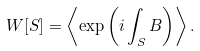Convert formula to latex. <formula><loc_0><loc_0><loc_500><loc_500>W [ S ] = \left \langle \exp \left ( i \int _ { S } B \right ) \right \rangle .</formula> 